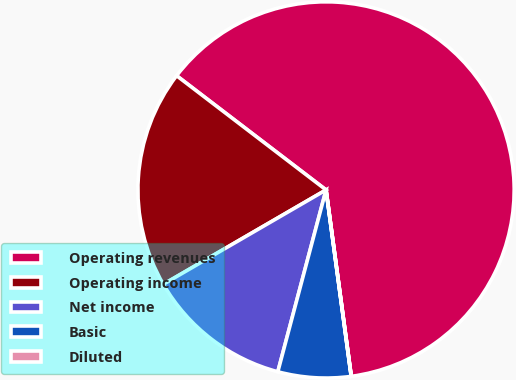Convert chart. <chart><loc_0><loc_0><loc_500><loc_500><pie_chart><fcel>Operating revenues<fcel>Operating income<fcel>Net income<fcel>Basic<fcel>Diluted<nl><fcel>62.47%<fcel>18.75%<fcel>12.51%<fcel>6.26%<fcel>0.01%<nl></chart> 